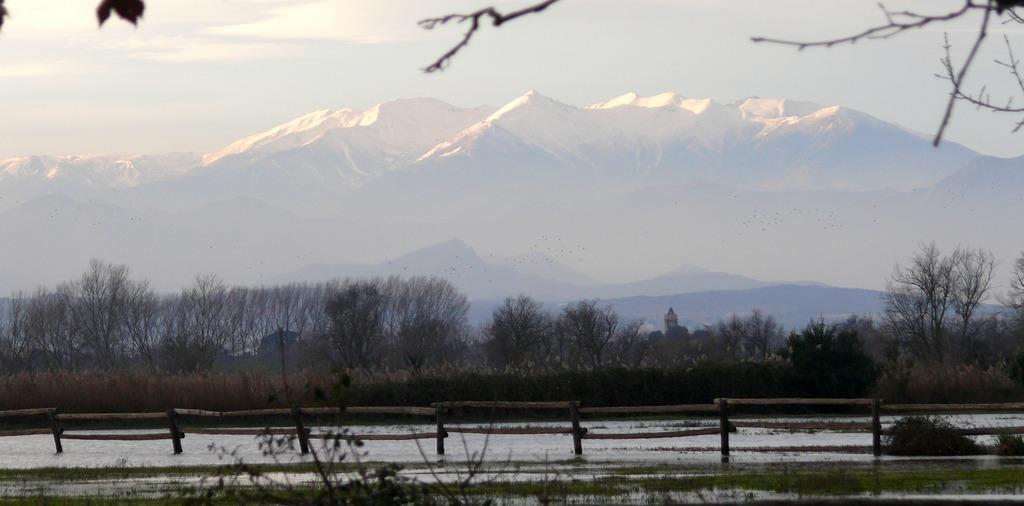In one or two sentences, can you explain what this image depicts? In this picture we can see fence, water, plants, trees, mountains and in the background we can see the sky. 